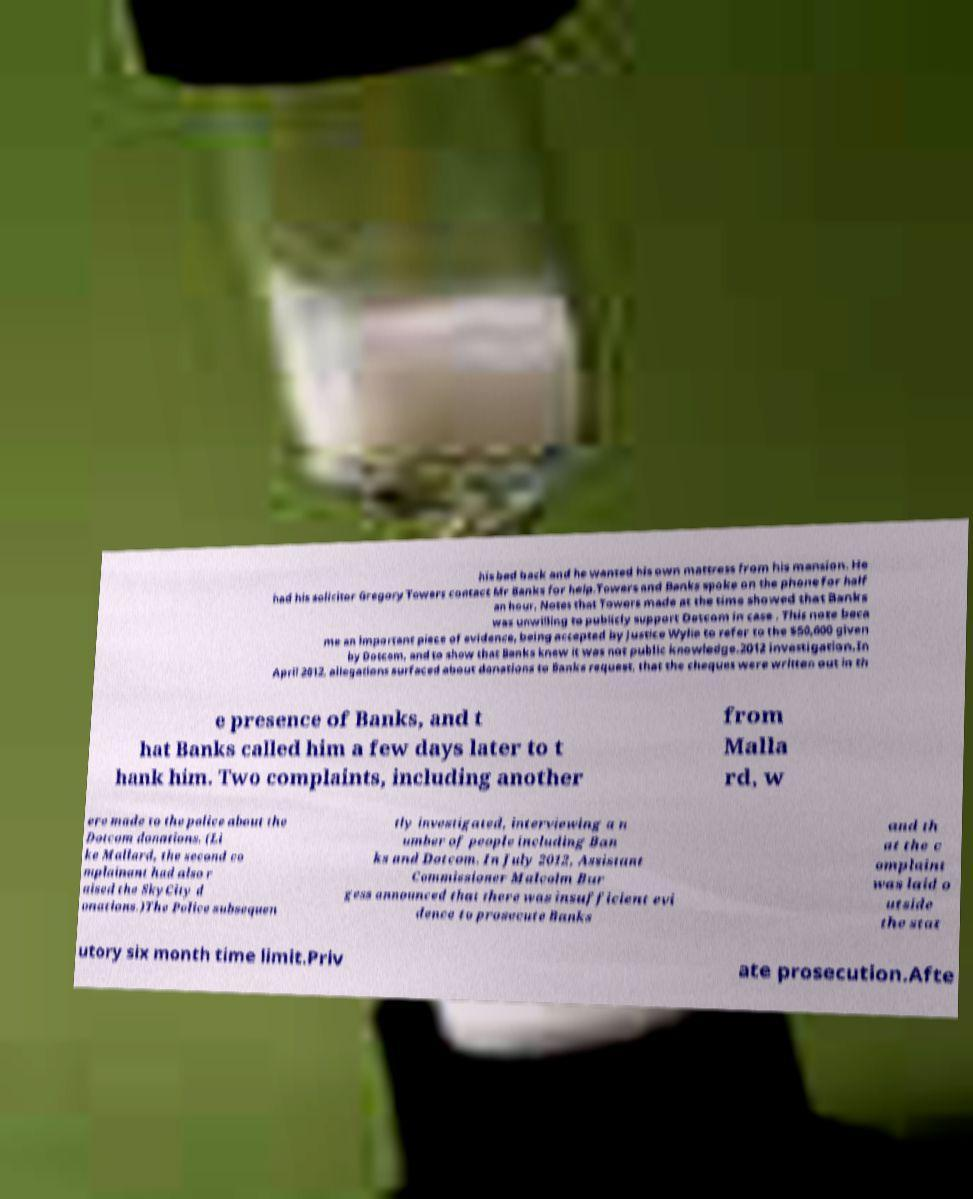Could you assist in decoding the text presented in this image and type it out clearly? his bad back and he wanted his own mattress from his mansion. He had his solicitor Gregory Towers contact Mr Banks for help.Towers and Banks spoke on the phone for half an hour. Notes that Towers made at the time showed that Banks was unwilling to publicly support Dotcom in case . This note beca me an important piece of evidence, being accepted by Justice Wylie to refer to the $50,000 given by Dotcom, and to show that Banks knew it was not public knowledge.2012 investigation.In April 2012, allegations surfaced about donations to Banks request, that the cheques were written out in th e presence of Banks, and t hat Banks called him a few days later to t hank him. Two complaints, including another from Malla rd, w ere made to the police about the Dotcom donations. (Li ke Mallard, the second co mplainant had also r aised the SkyCity d onations.)The Police subsequen tly investigated, interviewing a n umber of people including Ban ks and Dotcom. In July 2012, Assistant Commissioner Malcolm Bur gess announced that there was insufficient evi dence to prosecute Banks and th at the c omplaint was laid o utside the stat utory six month time limit.Priv ate prosecution.Afte 